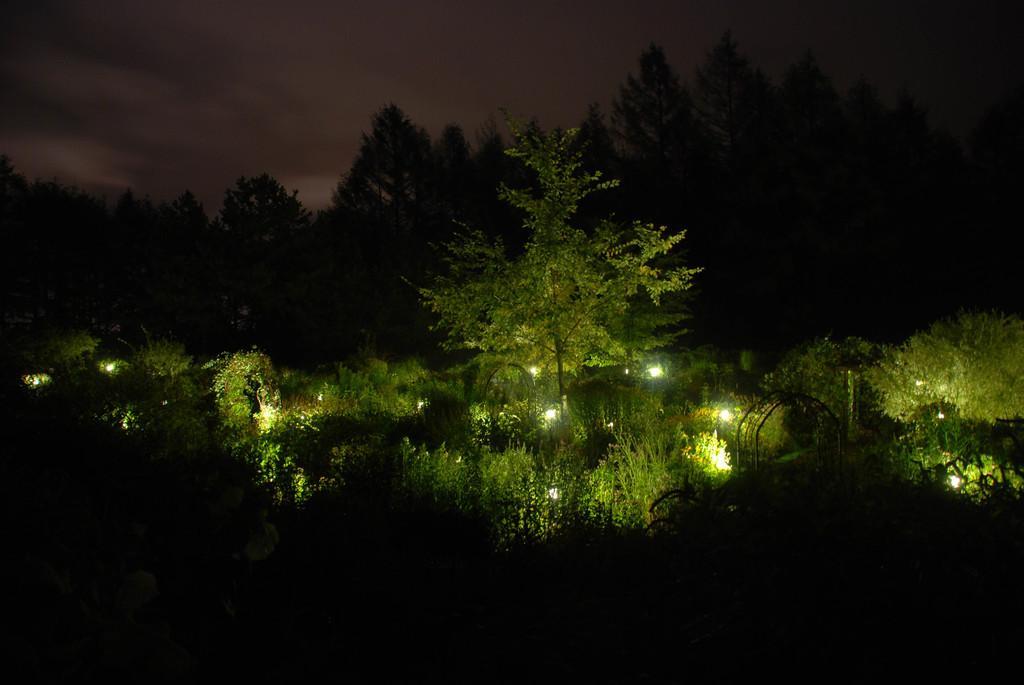How would you summarize this image in a sentence or two? In this image there are trees, lights. At the top of the image there is sky. 